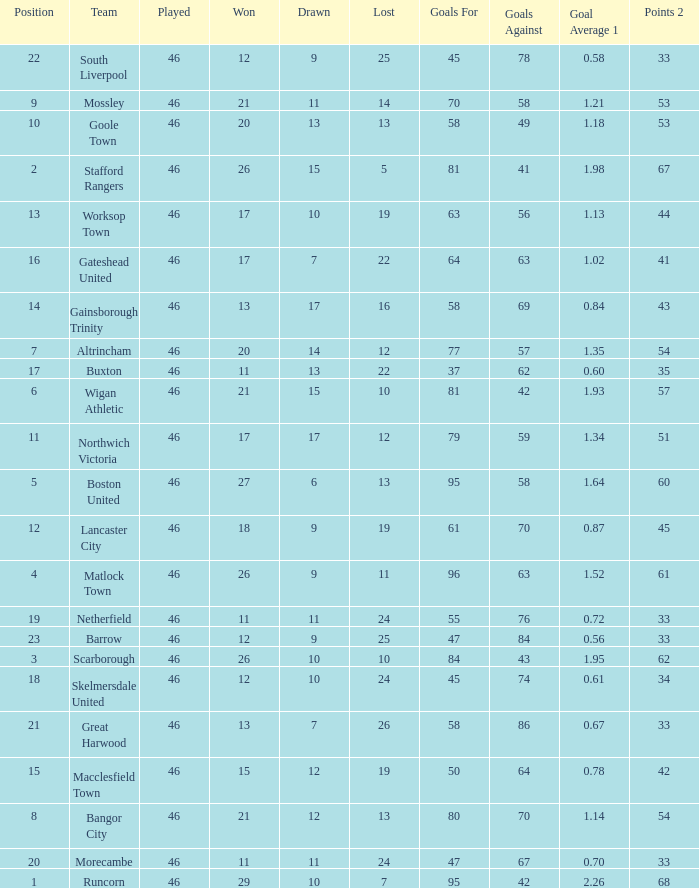How many times did the Lancaster City team play? 1.0. 